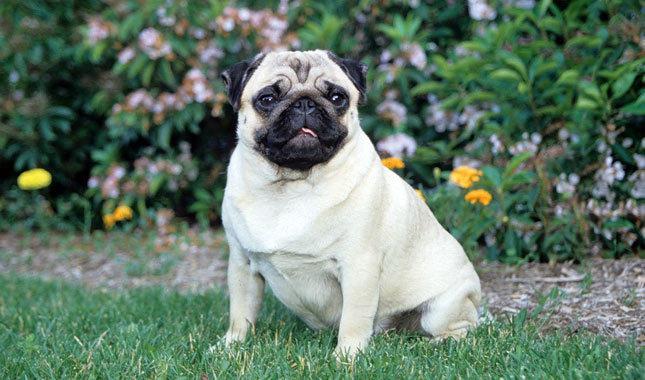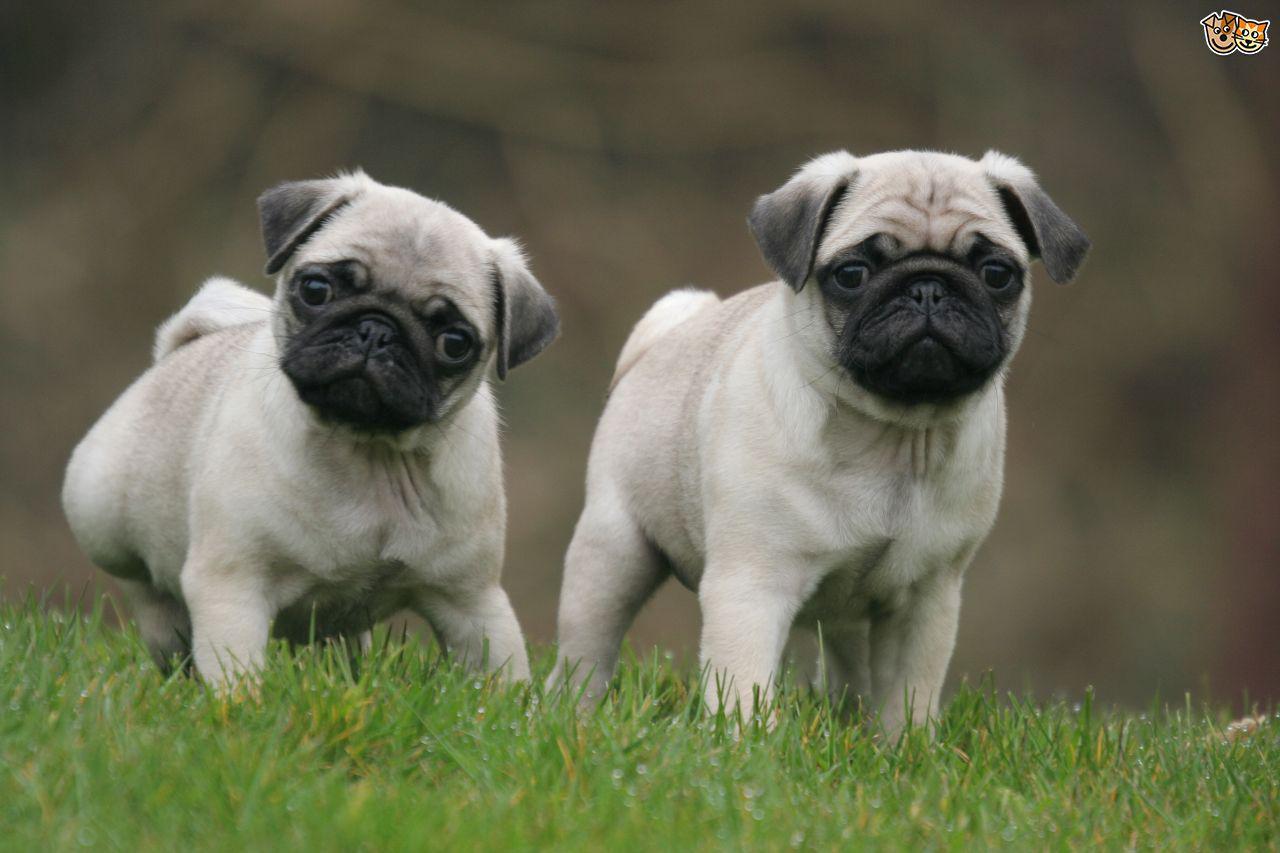The first image is the image on the left, the second image is the image on the right. Considering the images on both sides, is "Each image shows one dog sitting and one dog standing." valid? Answer yes or no. No. 